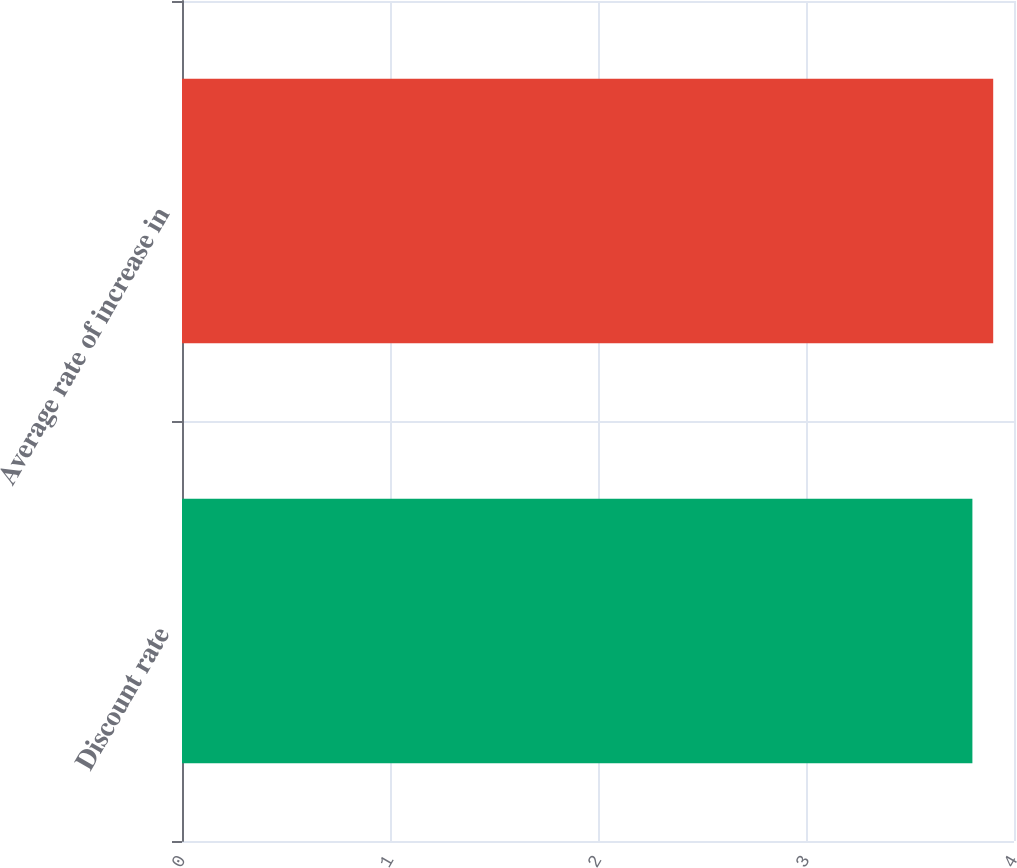Convert chart to OTSL. <chart><loc_0><loc_0><loc_500><loc_500><bar_chart><fcel>Discount rate<fcel>Average rate of increase in<nl><fcel>3.8<fcel>3.9<nl></chart> 